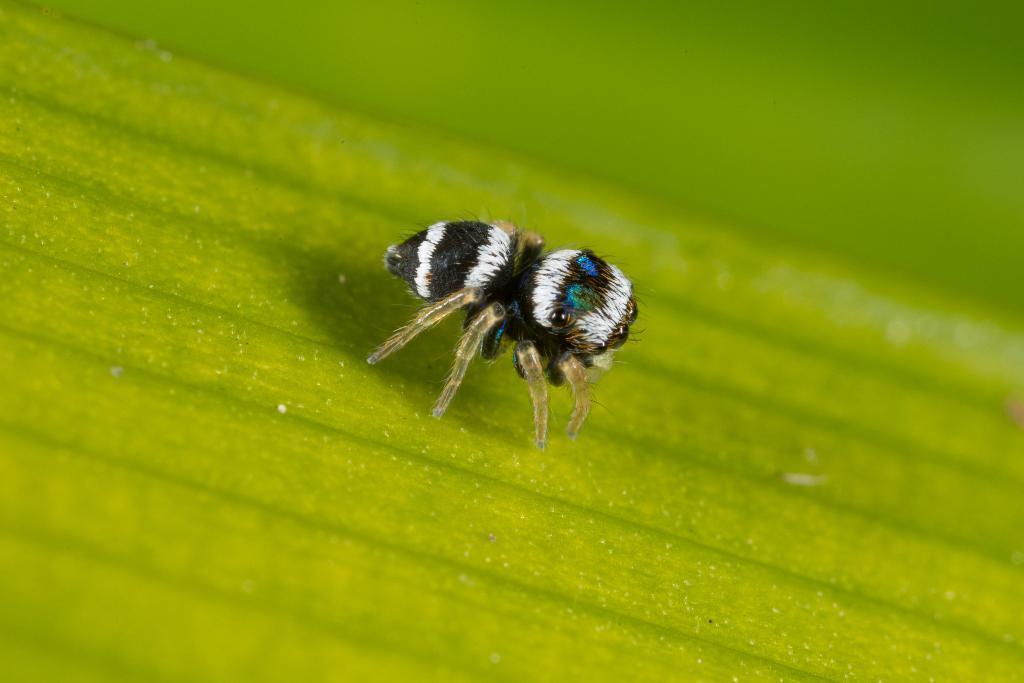Please provide a concise description of this image. In this image we can see an insect on the surface. 